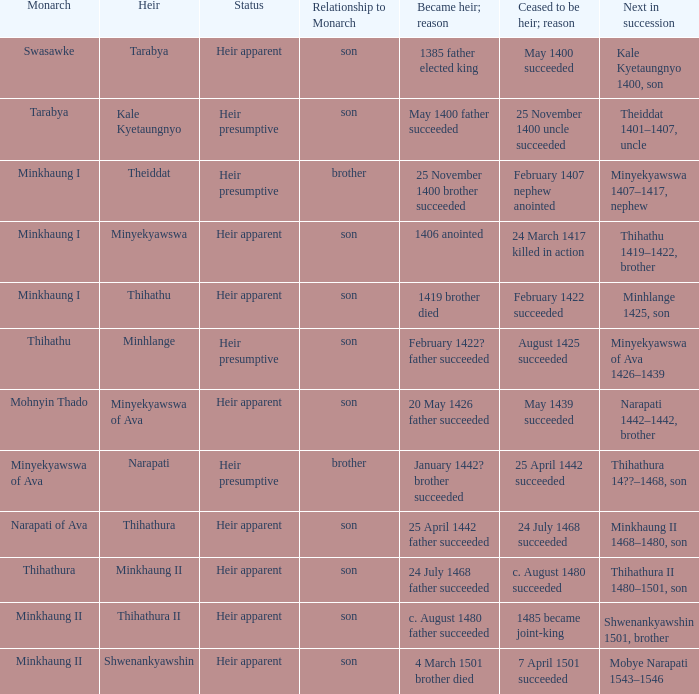How many reasons did the son and heir Kale Kyetaungnyo has when he ceased to be heir? 1.0. 